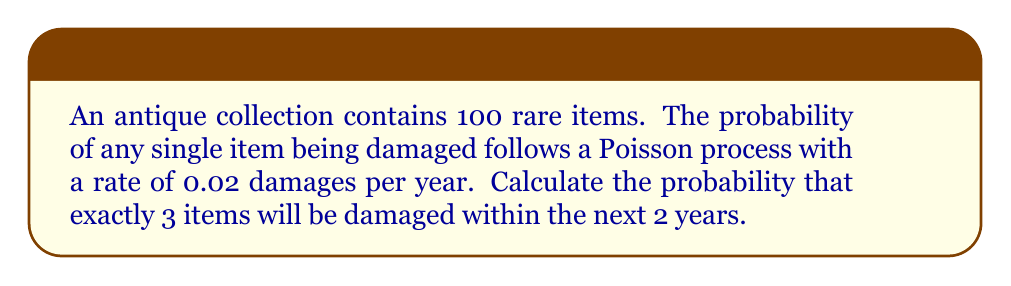Could you help me with this problem? To solve this problem, we'll use the Poisson distribution, which is appropriate for modeling rare events over time or space. Let's break it down step-by-step:

1) The Poisson distribution is given by the formula:

   $$P(X = k) = \frac{e^{-\lambda} \lambda^k}{k!}$$

   where:
   - $\lambda$ is the average number of events in the interval
   - $k$ is the number of events we're calculating the probability for

2) First, we need to calculate $\lambda$ for our scenario:
   - Rate per item per year = 0.02
   - Number of items = 100
   - Time period = 2 years
   
   $$\lambda = 0.02 \times 100 \times 2 = 4$$

3) Now we can plug our values into the Poisson formula:
   - $\lambda = 4$
   - $k = 3$

   $$P(X = 3) = \frac{e^{-4} 4^3}{3!}$$

4) Let's calculate this step-by-step:
   
   $$P(X = 3) = \frac{e^{-4} \times 64}{6}$$
   
   $$= \frac{0.0183 \times 64}{6}$$
   
   $$= \frac{1.1712}{6}$$
   
   $$= 0.1952$$

5) Therefore, the probability of exactly 3 items being damaged in 2 years is approximately 0.1952 or 19.52%.
Answer: 0.1952 